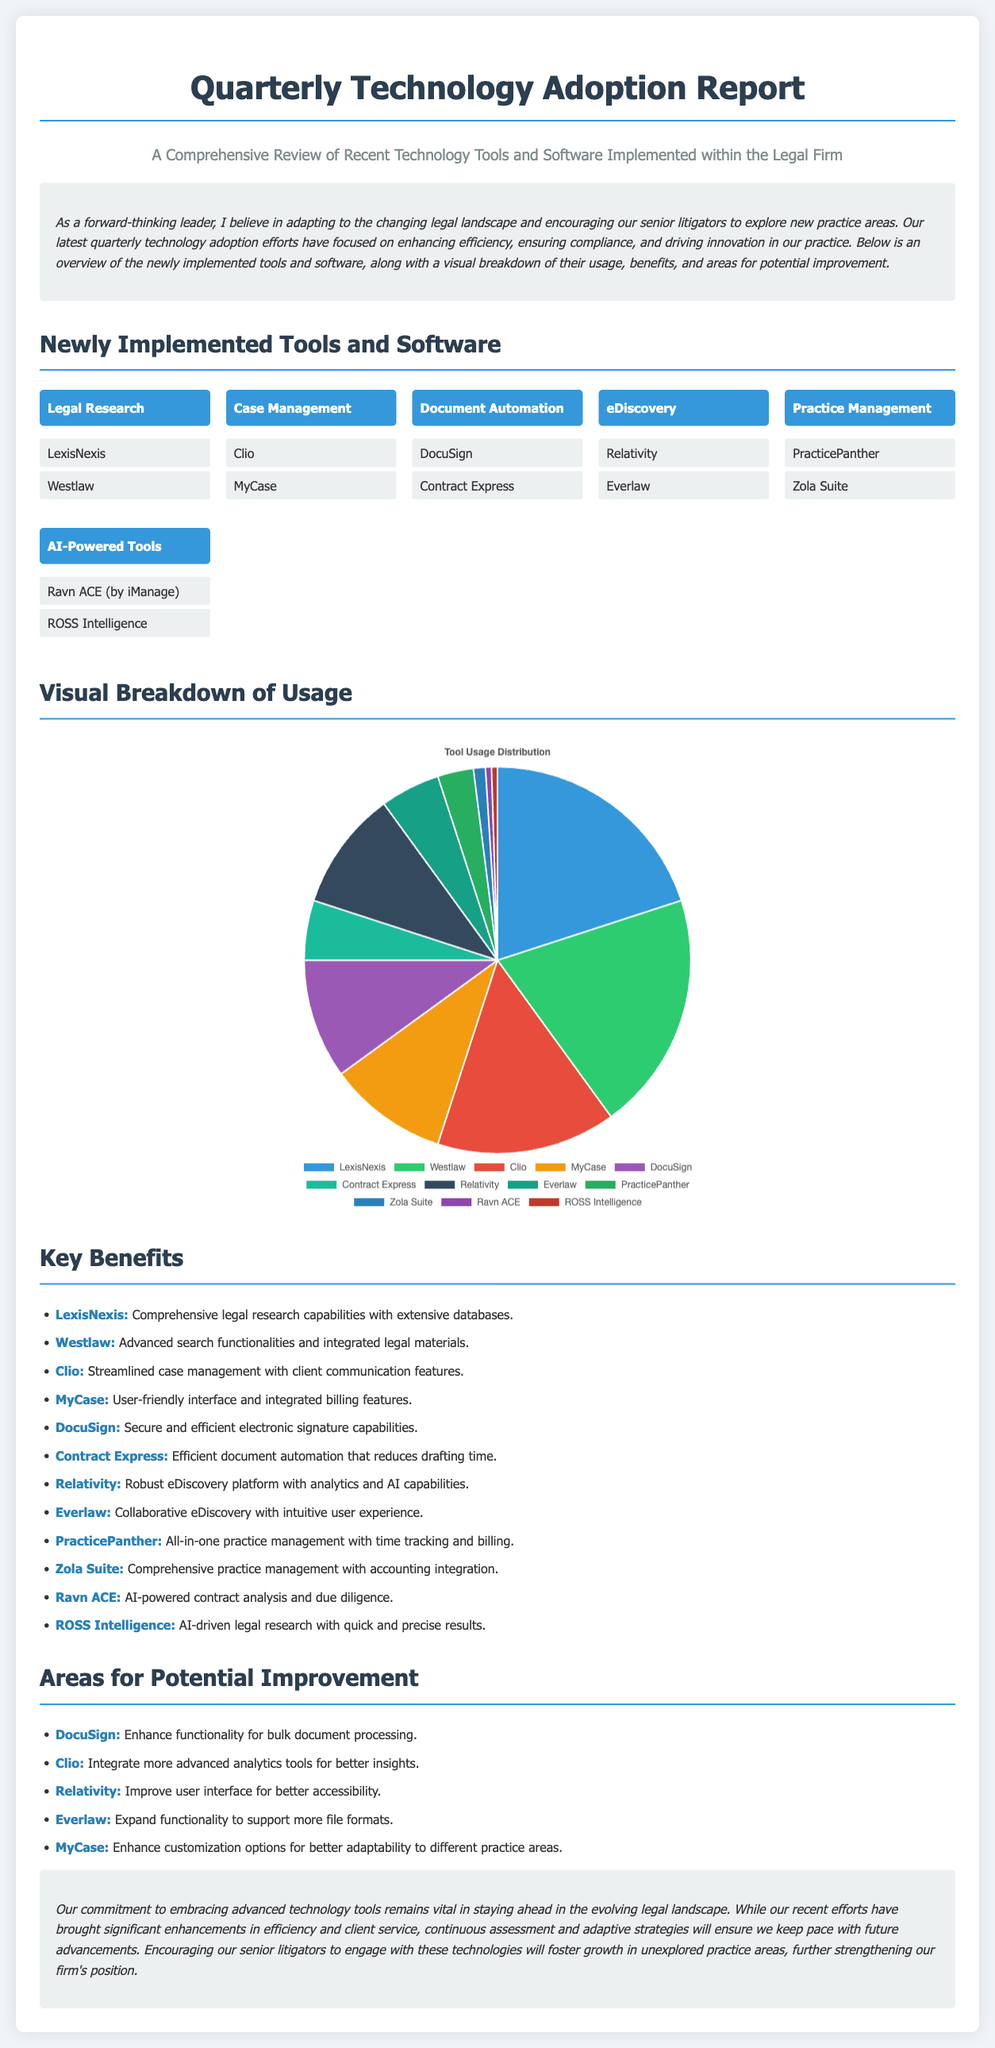What are the two tools used for Legal Research? The document lists LexisNexis and Westlaw under the Legal Research category.
Answer: LexisNexis, Westlaw Which tool provides electronic signature capabilities? DocuSign is mentioned as the tool for secure and efficient electronic signature capabilities.
Answer: DocuSign What is the percentage usage of Clio? The document indicates that Clio has a 15% usage share.
Answer: 15% What area does Ravn ACE focus on? Ravn ACE is identified as a tool for AI-powered contract analysis and due diligence.
Answer: AI-powered contract analysis Which tool is suggested for improvement in bulk document processing? The document identifies DocuSign as needing enhancements for bulk document processing.
Answer: DocuSign How many tools are listed under the Document Automation category? The document specifies two tools in the Document Automation category: DocuSign and Contract Express.
Answer: 2 What is the conclusion regarding the firm's commitment? The document concludes that the commitment to embracing advanced technology tools remains vital.
Answer: Vital Which tool has the lowest usage percentage? ROSS Intelligence and Ravn ACE both have the lowest usage percentage at 0.5%.
Answer: ROSS Intelligence, Ravn ACE 